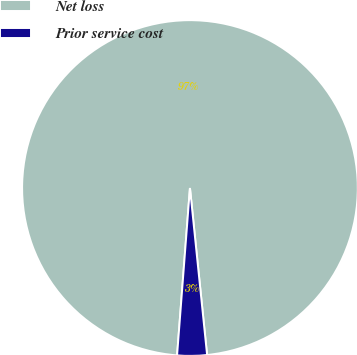<chart> <loc_0><loc_0><loc_500><loc_500><pie_chart><fcel>Net loss<fcel>Prior service cost<nl><fcel>97.15%<fcel>2.85%<nl></chart> 